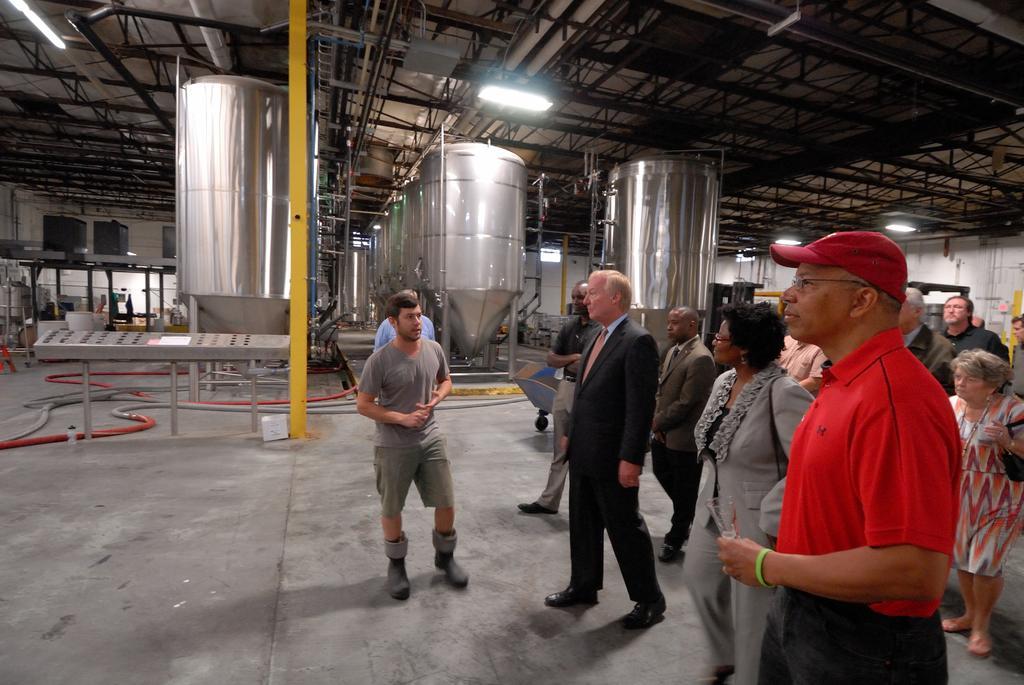Describe this image in one or two sentences. In this image there are few persons standing on the floor which is having few machines on it. A person wearing suit and tie is standing. Right side there is a person wearing a red shirt is having spectacles and cap. Behind there is a woman carrying a bag. Few lights are attached to the metal rods. 